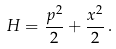Convert formula to latex. <formula><loc_0><loc_0><loc_500><loc_500>H = \frac { p ^ { 2 } } { 2 } + \frac { x ^ { 2 } } { 2 } \, .</formula> 